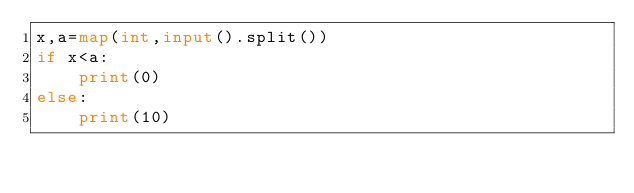<code> <loc_0><loc_0><loc_500><loc_500><_Python_>x,a=map(int,input().split())
if x<a:
    print(0)
else:
    print(10)</code> 